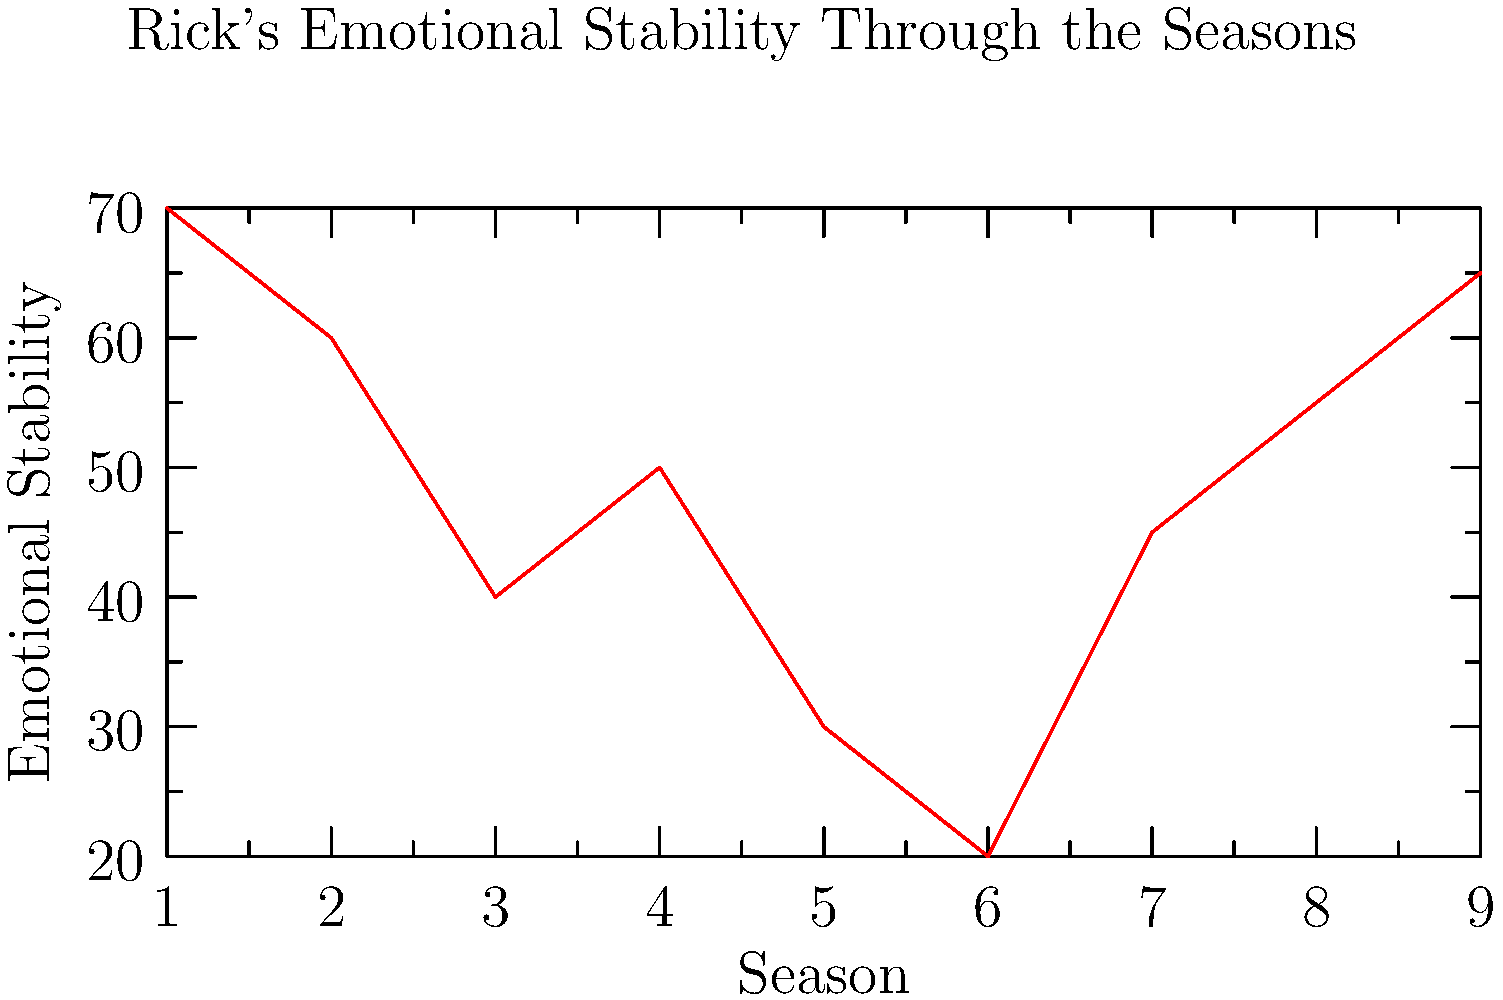Based on the line graph depicting Rick Grimes' emotional stability throughout the seasons of The Walking Dead, during which period does Rick appear to be at his lowest emotional point, and what might this suggest about his character development? 1. Analyze the graph: The y-axis represents emotional stability, while the x-axis shows the seasons.
2. Identify the lowest point: The graph reaches its lowest point at x=6, corresponding to Season 6.
3. Consider the context: Season 6 includes events like the Alexandria Safe-Zone struggles and the threat of the Saviors.
4. Interpret the trend: There's a sharp decline from Seasons 1 to 6, followed by a gradual increase.
5. Character development implications:
   a) The low point suggests Rick faced his greatest challenges in Season 6.
   b) The subsequent rise indicates resilience and adaptation.
   c) The overall arc shows Rick's journey through trauma, leadership struggles, and eventual growth.
6. Podcast relevance: This graph provides a visual aid for discussing Rick's character arc, emotional journey, and the series' narrative structure.
Answer: Season 6; represents Rick's greatest challenges and subsequent character growth. 